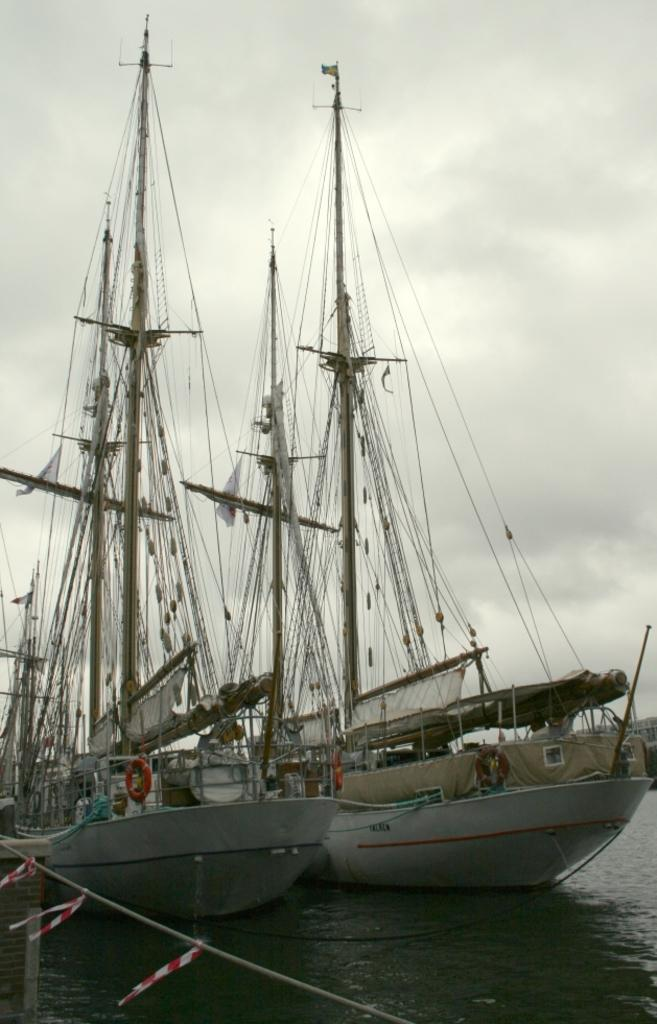How many boats can be seen in the image? There are two boats in the image. Where are the boats located? The boats are on the water. What safety feature is attached to the boats? There are life-saving tubes hanging from the boats. What other object can be seen in the image? There is a rope visible in the image. What part of the natural environment is visible in the image? The sky is visible in the image. What type of goldfish can be seen swimming near the boats in the image? There are no goldfish present in the image; it features two boats on the water with life-saving tubes and a rope. 